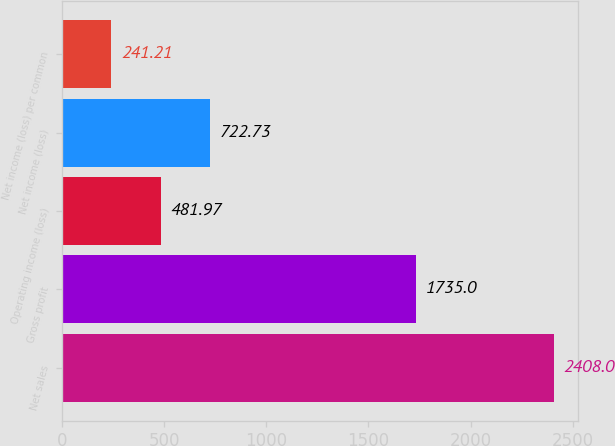Convert chart. <chart><loc_0><loc_0><loc_500><loc_500><bar_chart><fcel>Net sales<fcel>Gross profit<fcel>Operating income (loss)<fcel>Net income (loss)<fcel>Net income (loss) per common<nl><fcel>2408<fcel>1735<fcel>481.97<fcel>722.73<fcel>241.21<nl></chart> 